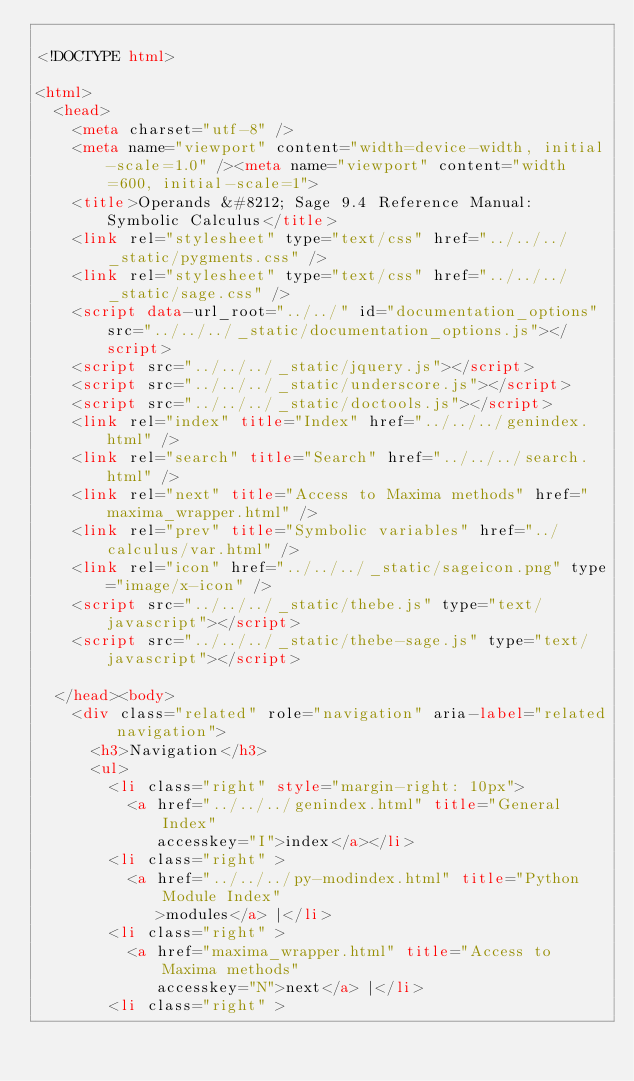<code> <loc_0><loc_0><loc_500><loc_500><_HTML_>
<!DOCTYPE html>

<html>
  <head>
    <meta charset="utf-8" />
    <meta name="viewport" content="width=device-width, initial-scale=1.0" /><meta name="viewport" content="width=600, initial-scale=1">
    <title>Operands &#8212; Sage 9.4 Reference Manual: Symbolic Calculus</title>
    <link rel="stylesheet" type="text/css" href="../../../_static/pygments.css" />
    <link rel="stylesheet" type="text/css" href="../../../_static/sage.css" />
    <script data-url_root="../../" id="documentation_options" src="../../../_static/documentation_options.js"></script>
    <script src="../../../_static/jquery.js"></script>
    <script src="../../../_static/underscore.js"></script>
    <script src="../../../_static/doctools.js"></script>
    <link rel="index" title="Index" href="../../../genindex.html" />
    <link rel="search" title="Search" href="../../../search.html" />
    <link rel="next" title="Access to Maxima methods" href="maxima_wrapper.html" />
    <link rel="prev" title="Symbolic variables" href="../calculus/var.html" />
    <link rel="icon" href="../../../_static/sageicon.png" type="image/x-icon" />
    <script src="../../../_static/thebe.js" type="text/javascript"></script>
    <script src="../../../_static/thebe-sage.js" type="text/javascript"></script>

  </head><body>
    <div class="related" role="navigation" aria-label="related navigation">
      <h3>Navigation</h3>
      <ul>
        <li class="right" style="margin-right: 10px">
          <a href="../../../genindex.html" title="General Index"
             accesskey="I">index</a></li>
        <li class="right" >
          <a href="../../../py-modindex.html" title="Python Module Index"
             >modules</a> |</li>
        <li class="right" >
          <a href="maxima_wrapper.html" title="Access to Maxima methods"
             accesskey="N">next</a> |</li>
        <li class="right" ></code> 